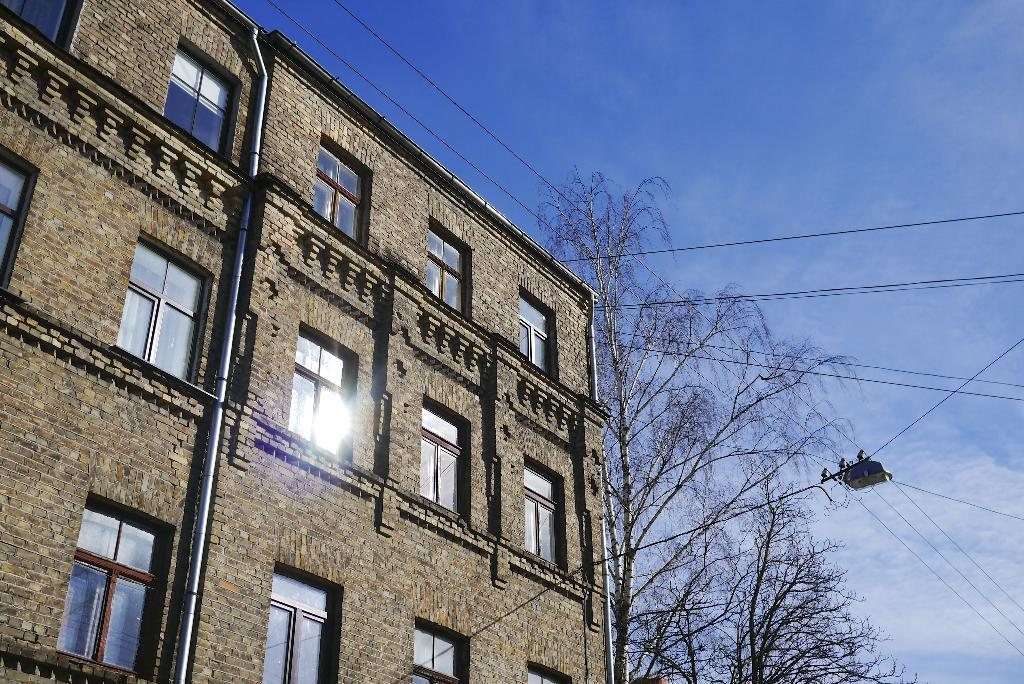What type of structure is present in the image? There is a building in the image. What feature can be seen on the building? The building has windows. What else is visible in the image besides the building? Electric wires and trees are visible in the image. What can be seen in the background of the image? The sky is visible in the image. What type of powder is being used to clean the windows of the building in the image? There is no indication of any cleaning activity or powder being used in the image. 